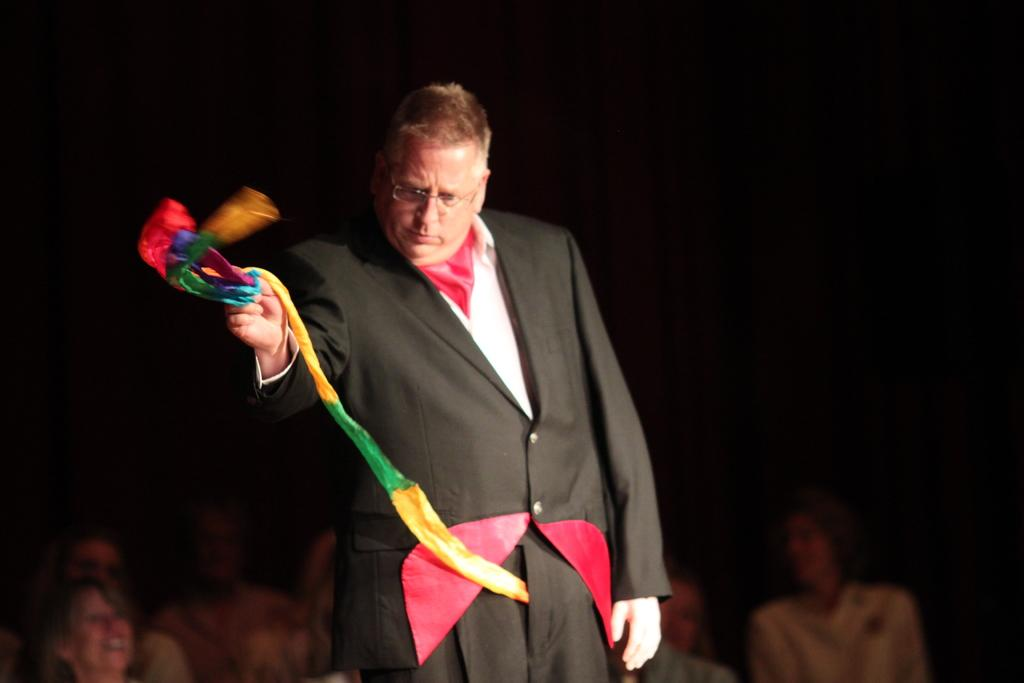What is the man in the image doing? The man is standing in the image and holding a colorful cloth. Who else is present in the image besides the man? There is a group of people at the bottom of the image. How would you describe the overall lighting in the image? The background of the image appears dark. What type of orange is the man using as a prop in the image? There is no orange present in the image; the man is holding a colorful cloth. Is there a gun visible in the image? No, there is no gun present in the image. 